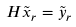Convert formula to latex. <formula><loc_0><loc_0><loc_500><loc_500>H \tilde { x } _ { r } = \tilde { y } _ { r }</formula> 